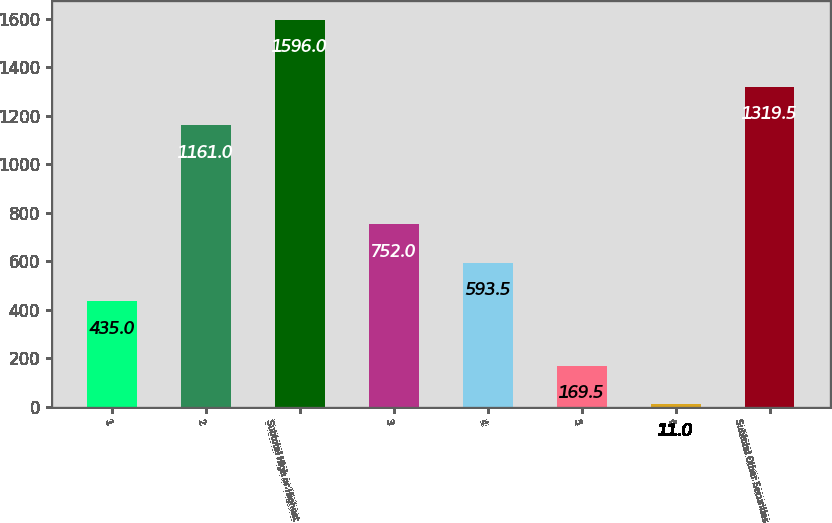<chart> <loc_0><loc_0><loc_500><loc_500><bar_chart><fcel>1<fcel>2<fcel>Subtotal High or Highest<fcel>3<fcel>4<fcel>5<fcel>6<fcel>Subtotal Other Securities<nl><fcel>435<fcel>1161<fcel>1596<fcel>752<fcel>593.5<fcel>169.5<fcel>11<fcel>1319.5<nl></chart> 